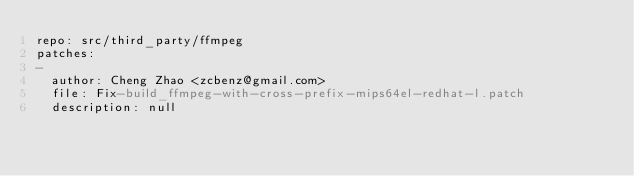Convert code to text. <code><loc_0><loc_0><loc_500><loc_500><_YAML_>repo: src/third_party/ffmpeg
patches:
-
  author: Cheng Zhao <zcbenz@gmail.com>
  file: Fix-build_ffmpeg-with-cross-prefix-mips64el-redhat-l.patch
  description: null
</code> 